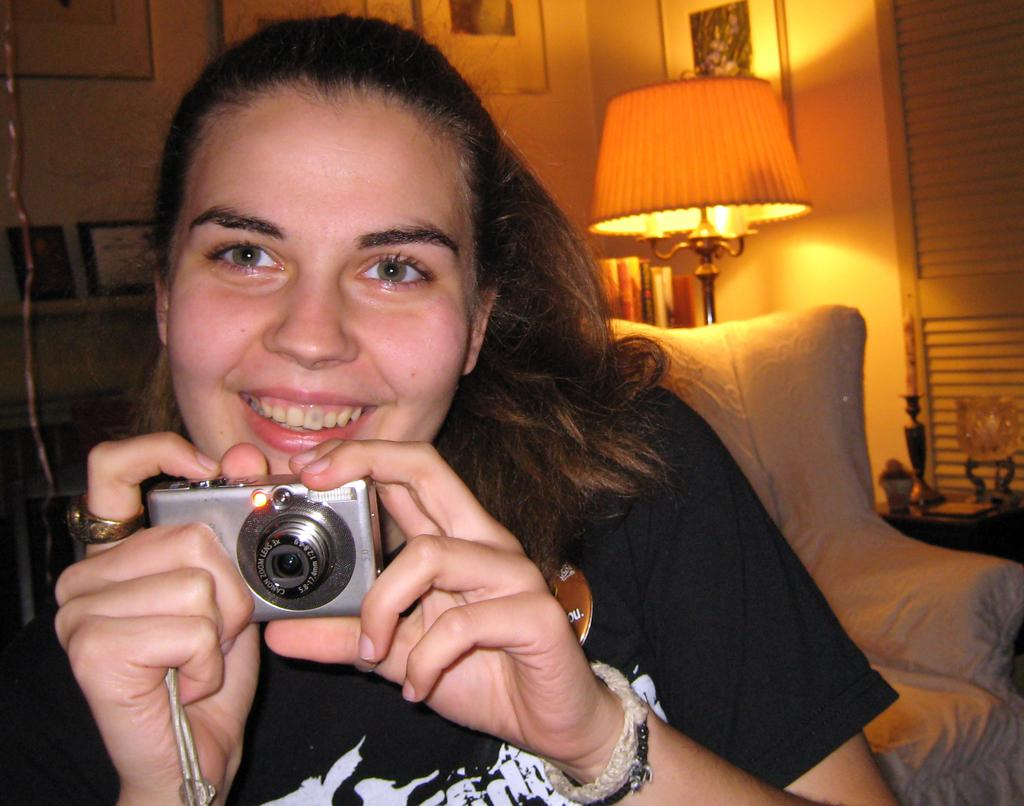Who is the main subject in the image? There is a woman in the image. What is the woman holding in her hands? The woman is holding a camera in her hands. What can be seen in the background of the image? There is a chair, a lamp, objects on a table, frames on the wall, and other objects visible in the background of the image. How many tin spiders are crawling on the woman's camera during the rainstorm in the image? There are no tin spiders or rainstorm present in the image. The woman is holding a camera, and there are no spiders or rain mentioned in the facts provided. 